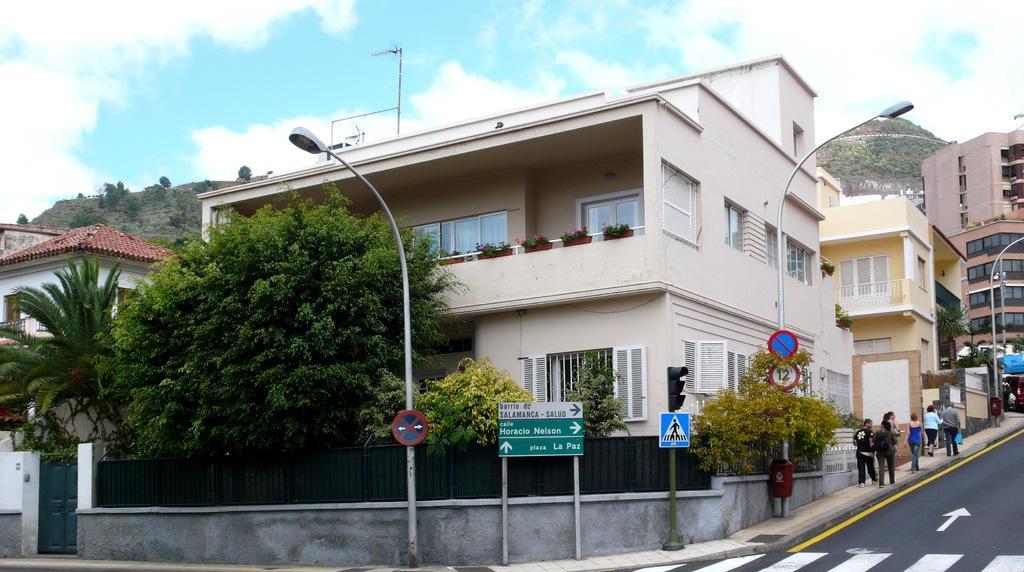Describe this image in one or two sentences. As we can see in the image there are buildings, street lamps, sign poles, trees, plants and hills. At the top there is sky and clouds. 